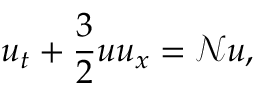Convert formula to latex. <formula><loc_0><loc_0><loc_500><loc_500>u _ { t } + \frac { 3 } { 2 } u u _ { x } = \ m a t h s c r { N } u ,</formula> 